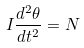Convert formula to latex. <formula><loc_0><loc_0><loc_500><loc_500>I \frac { d ^ { 2 } \theta } { d t ^ { 2 } } = N</formula> 